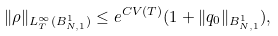<formula> <loc_0><loc_0><loc_500><loc_500>\| \rho \| _ { L _ { T } ^ { \infty } ( B ^ { 1 } _ { N , 1 } ) } \leq e ^ { C V ( T ) } ( 1 + \| q _ { 0 } \| _ { B ^ { 1 } _ { N , 1 } } ) ,</formula> 